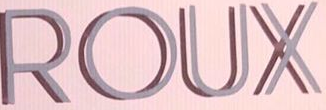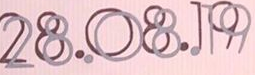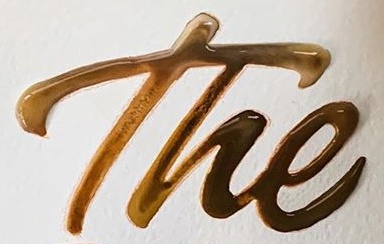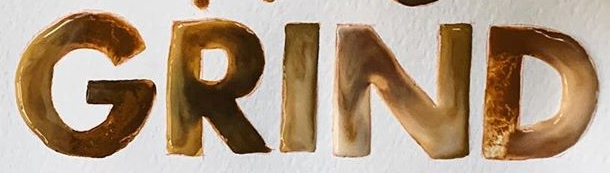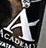Read the text from these images in sequence, separated by a semicolon. ROUX; 28.08.19; The; GRIND; A 